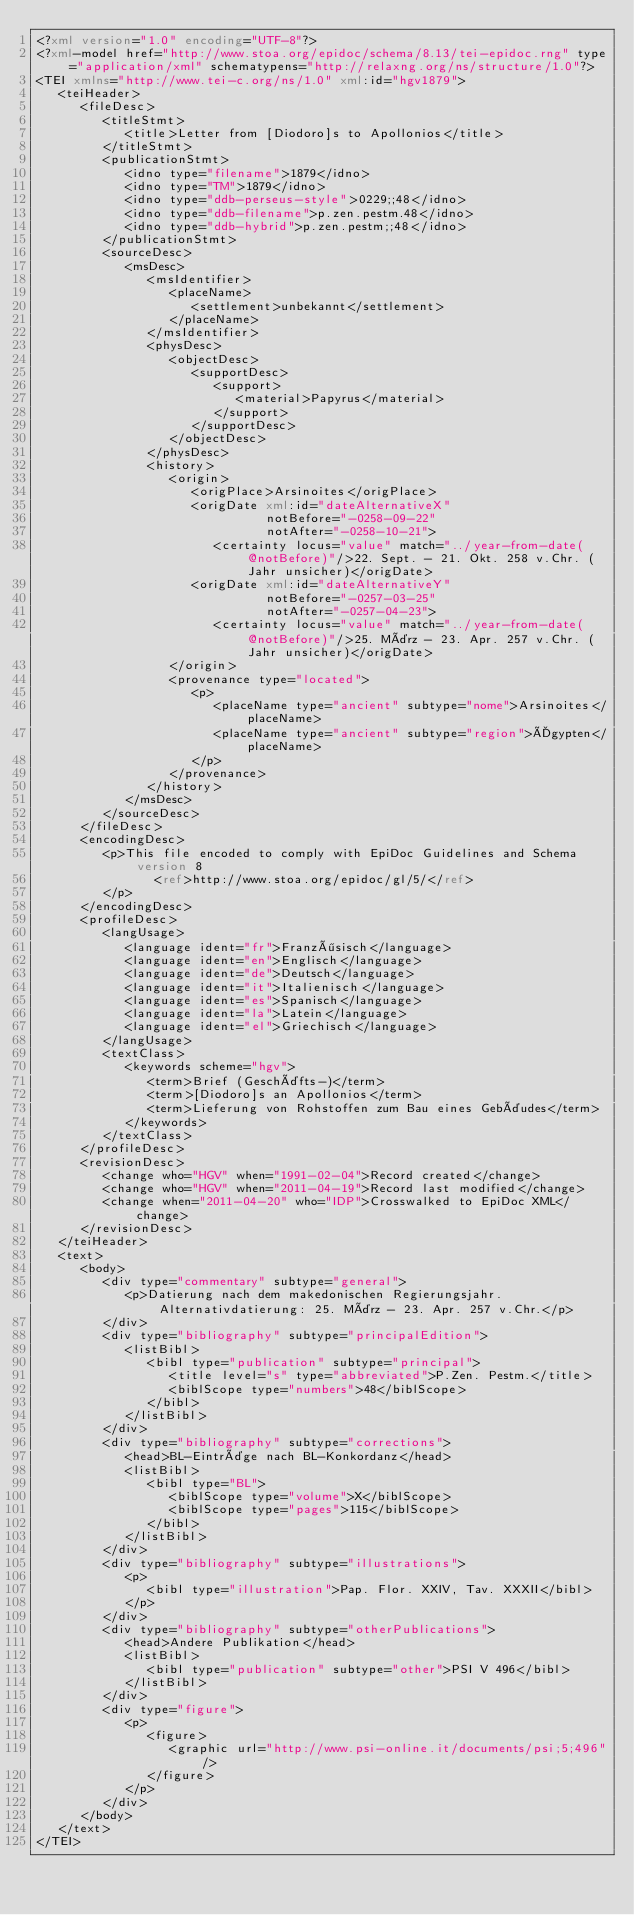<code> <loc_0><loc_0><loc_500><loc_500><_XML_><?xml version="1.0" encoding="UTF-8"?>
<?xml-model href="http://www.stoa.org/epidoc/schema/8.13/tei-epidoc.rng" type="application/xml" schematypens="http://relaxng.org/ns/structure/1.0"?>
<TEI xmlns="http://www.tei-c.org/ns/1.0" xml:id="hgv1879">
   <teiHeader>
      <fileDesc>
         <titleStmt>
            <title>Letter from [Diodoro]s to Apollonios</title>
         </titleStmt>
         <publicationStmt>
            <idno type="filename">1879</idno>
            <idno type="TM">1879</idno>
            <idno type="ddb-perseus-style">0229;;48</idno>
            <idno type="ddb-filename">p.zen.pestm.48</idno>
            <idno type="ddb-hybrid">p.zen.pestm;;48</idno>
         </publicationStmt>
         <sourceDesc>
            <msDesc>
               <msIdentifier>
                  <placeName>
                     <settlement>unbekannt</settlement>
                  </placeName>
               </msIdentifier>
               <physDesc>
                  <objectDesc>
                     <supportDesc>
                        <support>
                           <material>Papyrus</material>
                        </support>
                     </supportDesc>
                  </objectDesc>
               </physDesc>
               <history>
                  <origin>
                     <origPlace>Arsinoites</origPlace>
                     <origDate xml:id="dateAlternativeX"
                               notBefore="-0258-09-22"
                               notAfter="-0258-10-21">
                        <certainty locus="value" match="../year-from-date(@notBefore)"/>22. Sept. - 21. Okt. 258 v.Chr. (Jahr unsicher)</origDate>
                     <origDate xml:id="dateAlternativeY"
                               notBefore="-0257-03-25"
                               notAfter="-0257-04-23">
                        <certainty locus="value" match="../year-from-date(@notBefore)"/>25. März - 23. Apr. 257 v.Chr. (Jahr unsicher)</origDate>
                  </origin>
                  <provenance type="located">
                     <p>
                        <placeName type="ancient" subtype="nome">Arsinoites</placeName>
                        <placeName type="ancient" subtype="region">Ägypten</placeName>
                     </p>
                  </provenance>
               </history>
            </msDesc>
         </sourceDesc>
      </fileDesc>
      <encodingDesc>
         <p>This file encoded to comply with EpiDoc Guidelines and Schema version 8
                <ref>http://www.stoa.org/epidoc/gl/5/</ref>
         </p>
      </encodingDesc>
      <profileDesc>
         <langUsage>
            <language ident="fr">Französisch</language>
            <language ident="en">Englisch</language>
            <language ident="de">Deutsch</language>
            <language ident="it">Italienisch</language>
            <language ident="es">Spanisch</language>
            <language ident="la">Latein</language>
            <language ident="el">Griechisch</language>
         </langUsage>
         <textClass>
            <keywords scheme="hgv">
               <term>Brief (Geschäfts-)</term>
               <term>[Diodoro]s an Apollonios</term>
               <term>Lieferung von Rohstoffen zum Bau eines Gebäudes</term>
            </keywords>
         </textClass>
      </profileDesc>
      <revisionDesc>
         <change who="HGV" when="1991-02-04">Record created</change>
         <change who="HGV" when="2011-04-19">Record last modified</change>
         <change when="2011-04-20" who="IDP">Crosswalked to EpiDoc XML</change>
      </revisionDesc>
   </teiHeader>
   <text>
      <body>
         <div type="commentary" subtype="general">
            <p>Datierung nach dem makedonischen Regierungsjahr. Alternativdatierung: 25. März - 23. Apr. 257 v.Chr.</p>
         </div>
         <div type="bibliography" subtype="principalEdition">
            <listBibl>
               <bibl type="publication" subtype="principal">
                  <title level="s" type="abbreviated">P.Zen. Pestm.</title>
                  <biblScope type="numbers">48</biblScope>
               </bibl>
            </listBibl>
         </div>
         <div type="bibliography" subtype="corrections">
            <head>BL-Einträge nach BL-Konkordanz</head>
            <listBibl>
               <bibl type="BL">
                  <biblScope type="volume">X</biblScope>
                  <biblScope type="pages">115</biblScope>
               </bibl>
            </listBibl>
         </div>
         <div type="bibliography" subtype="illustrations">
            <p>
               <bibl type="illustration">Pap. Flor. XXIV, Tav. XXXII</bibl>
            </p>
         </div>
         <div type="bibliography" subtype="otherPublications">
            <head>Andere Publikation</head>
            <listBibl>
               <bibl type="publication" subtype="other">PSI V 496</bibl>
            </listBibl>
         </div>
         <div type="figure">
            <p>
               <figure>
                  <graphic url="http://www.psi-online.it/documents/psi;5;496"/>
               </figure>
            </p>
         </div>
      </body>
   </text>
</TEI>
</code> 